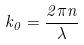<formula> <loc_0><loc_0><loc_500><loc_500>k _ { 0 } = \frac { 2 \pi n } { \lambda }</formula> 